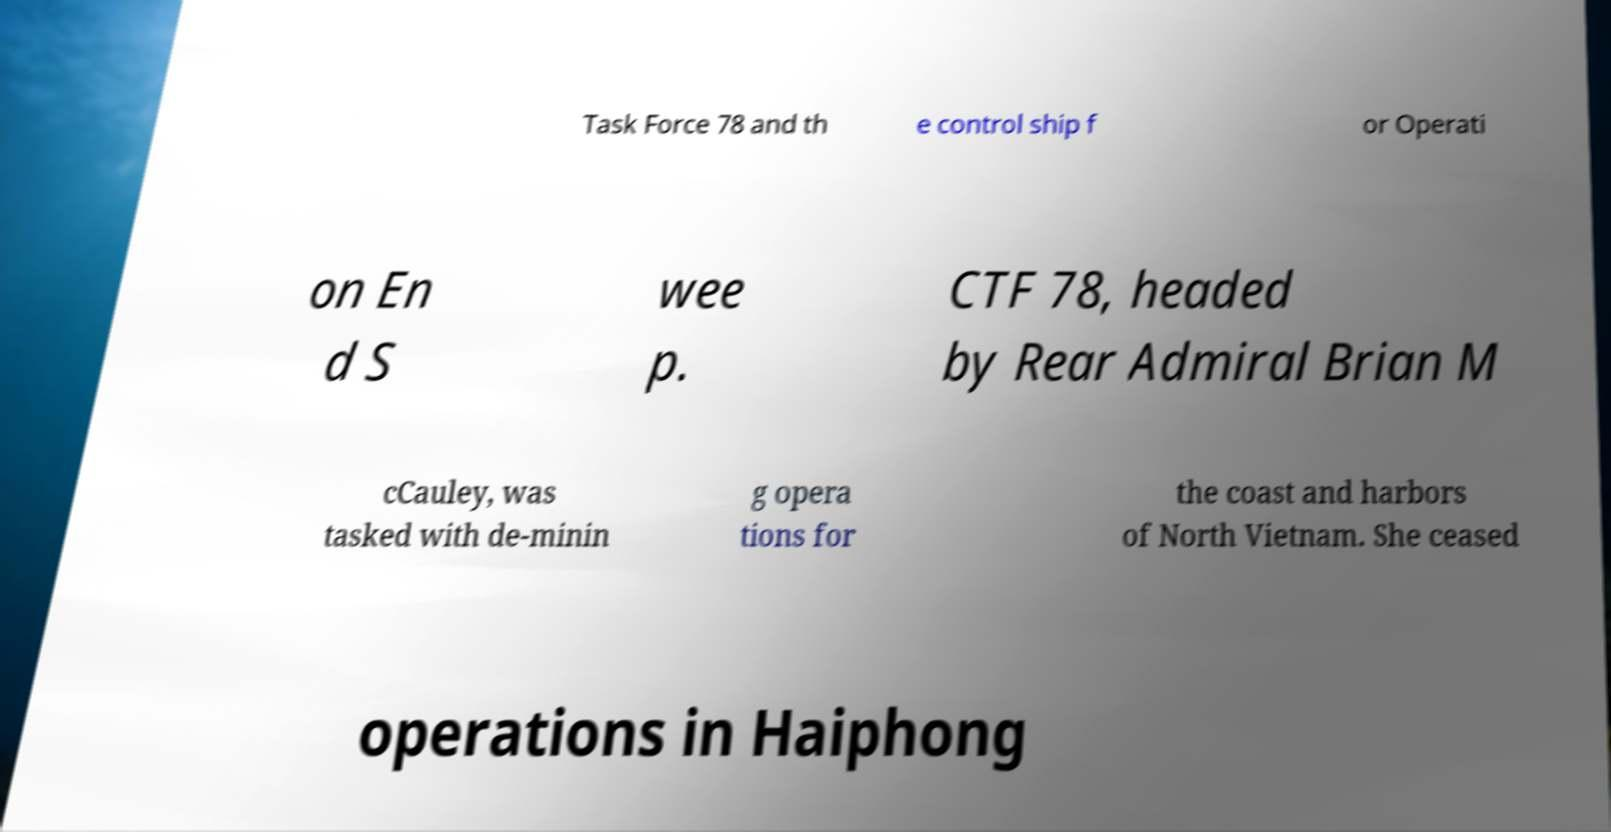Could you extract and type out the text from this image? Task Force 78 and th e control ship f or Operati on En d S wee p. CTF 78, headed by Rear Admiral Brian M cCauley, was tasked with de-minin g opera tions for the coast and harbors of North Vietnam. She ceased operations in Haiphong 